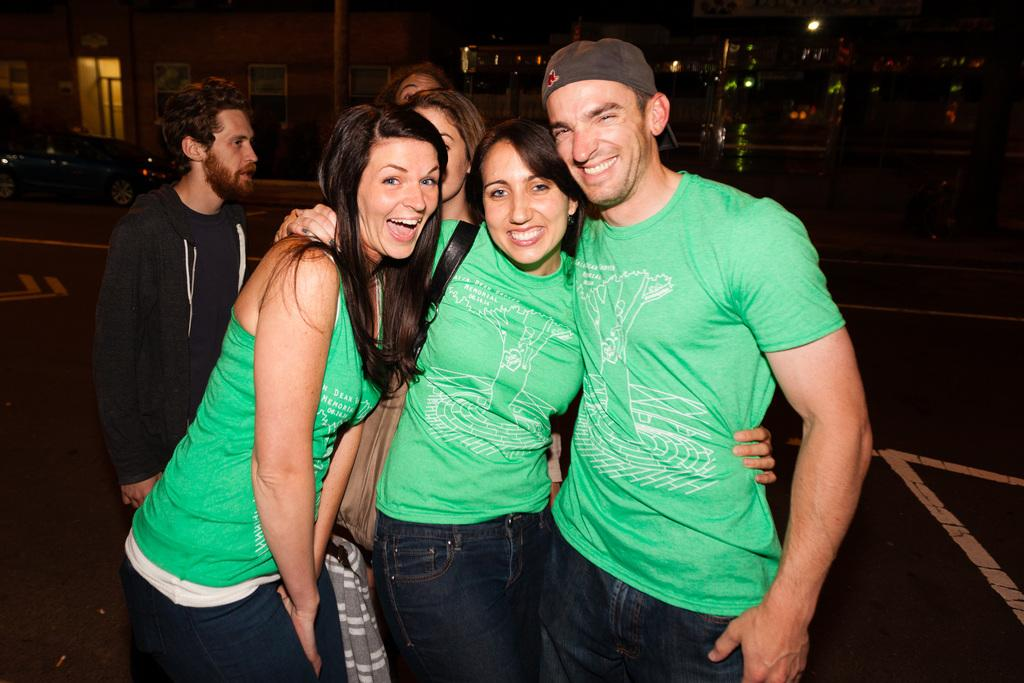What can be seen in the image? There are people standing in the image. What are the people wearing? The people are wearing green t-shirts and jeans. What can be seen in the background of the image? There are vehicles and a building visible in the background. What else is present in the image? Lights are present in the image, and a woman is wearing a bag. What type of appliance can be seen in the tent in the image? There is no tent or appliance present in the image. 